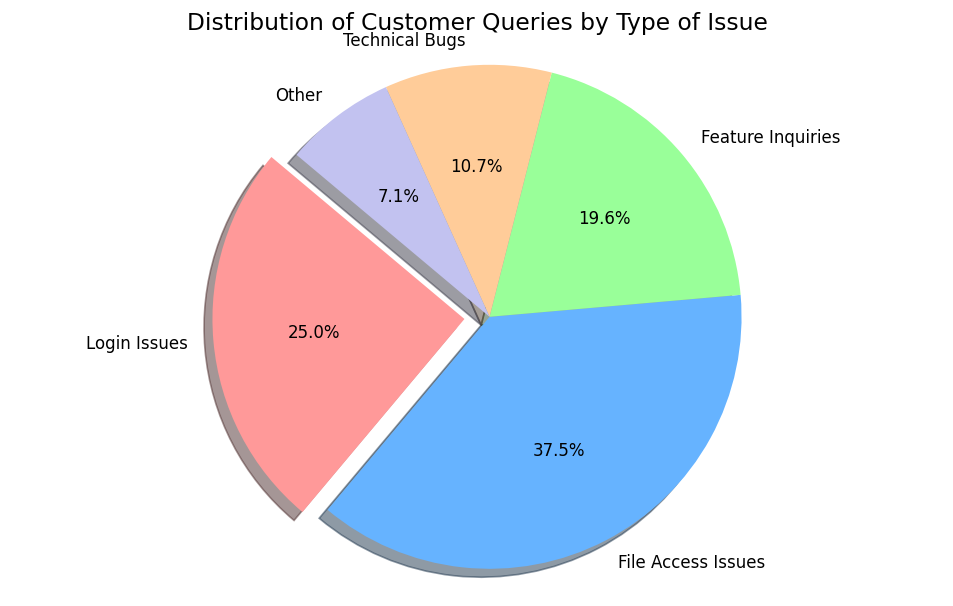How many customer queries are related to login issues? Look at the slice labeled "Login Issues" to find the count, or check the percentage and convert it to the total count. The count for "Login Issues" is directly given as 350.
Answer: 350 Which issue type has the highest occurrence? Identify the largest slice on the pie chart and read its label. The largest slice represents "File Access Issues".
Answer: File Access Issues What percentage of customer queries are related to technical bugs? Look at the slice labeled "Technical Bugs" and read the percentage shown inside or near it.
Answer: 10.0% What is the sum of customer queries related to login issues and file access issues? Find the counts for both "Login Issues" (350) and "File Access Issues" (525), then sum these numbers up. 350 + 525 = 875.
Answer: 875 Is the number of feature inquiries more than the number of technical bugs? Compare the counts for "Feature Inquiries" and "Technical Bugs". Feature Inquiries are 275 and Technical Bugs are 150. Since 275 > 150, the answer is yes.
Answer: Yes Which segment is highlighted or exploded in the pie chart? Identify the slice that is separated from the rest of the pie. This is the one labeled "Login Issues."
Answer: Login Issues What visual element distinguishes the slice for login issues from the others? Observe the chart and note that the slice for "Login Issues" is the only one separated or "exploded" from the pie.
Answer: It is exploded If we combine the percentages of feature inquiries and other issues, how much would it be? Read the percentages for "Feature Inquiries" (15.8%) and "Other" (5.8%), then sum these percentages up. 15.8% + 5.8% = 21.6%.
Answer: 21.6% What is the second most common type of customer query? Determine the second largest slice on the pie chart. After "File Access Issues", the next largest slice is "Login Issues".
Answer: Login Issues What is the ratio of file access issues to technical bugs? Find the counts for both "File Access Issues" (525) and "Technical Bugs" (150), then calculate the ratio as 525:150. Simplify this ratio. 525/150 = 3.5/1, hence the simplified ratio is approximately 3.5:1.
Answer: 3.5:1 